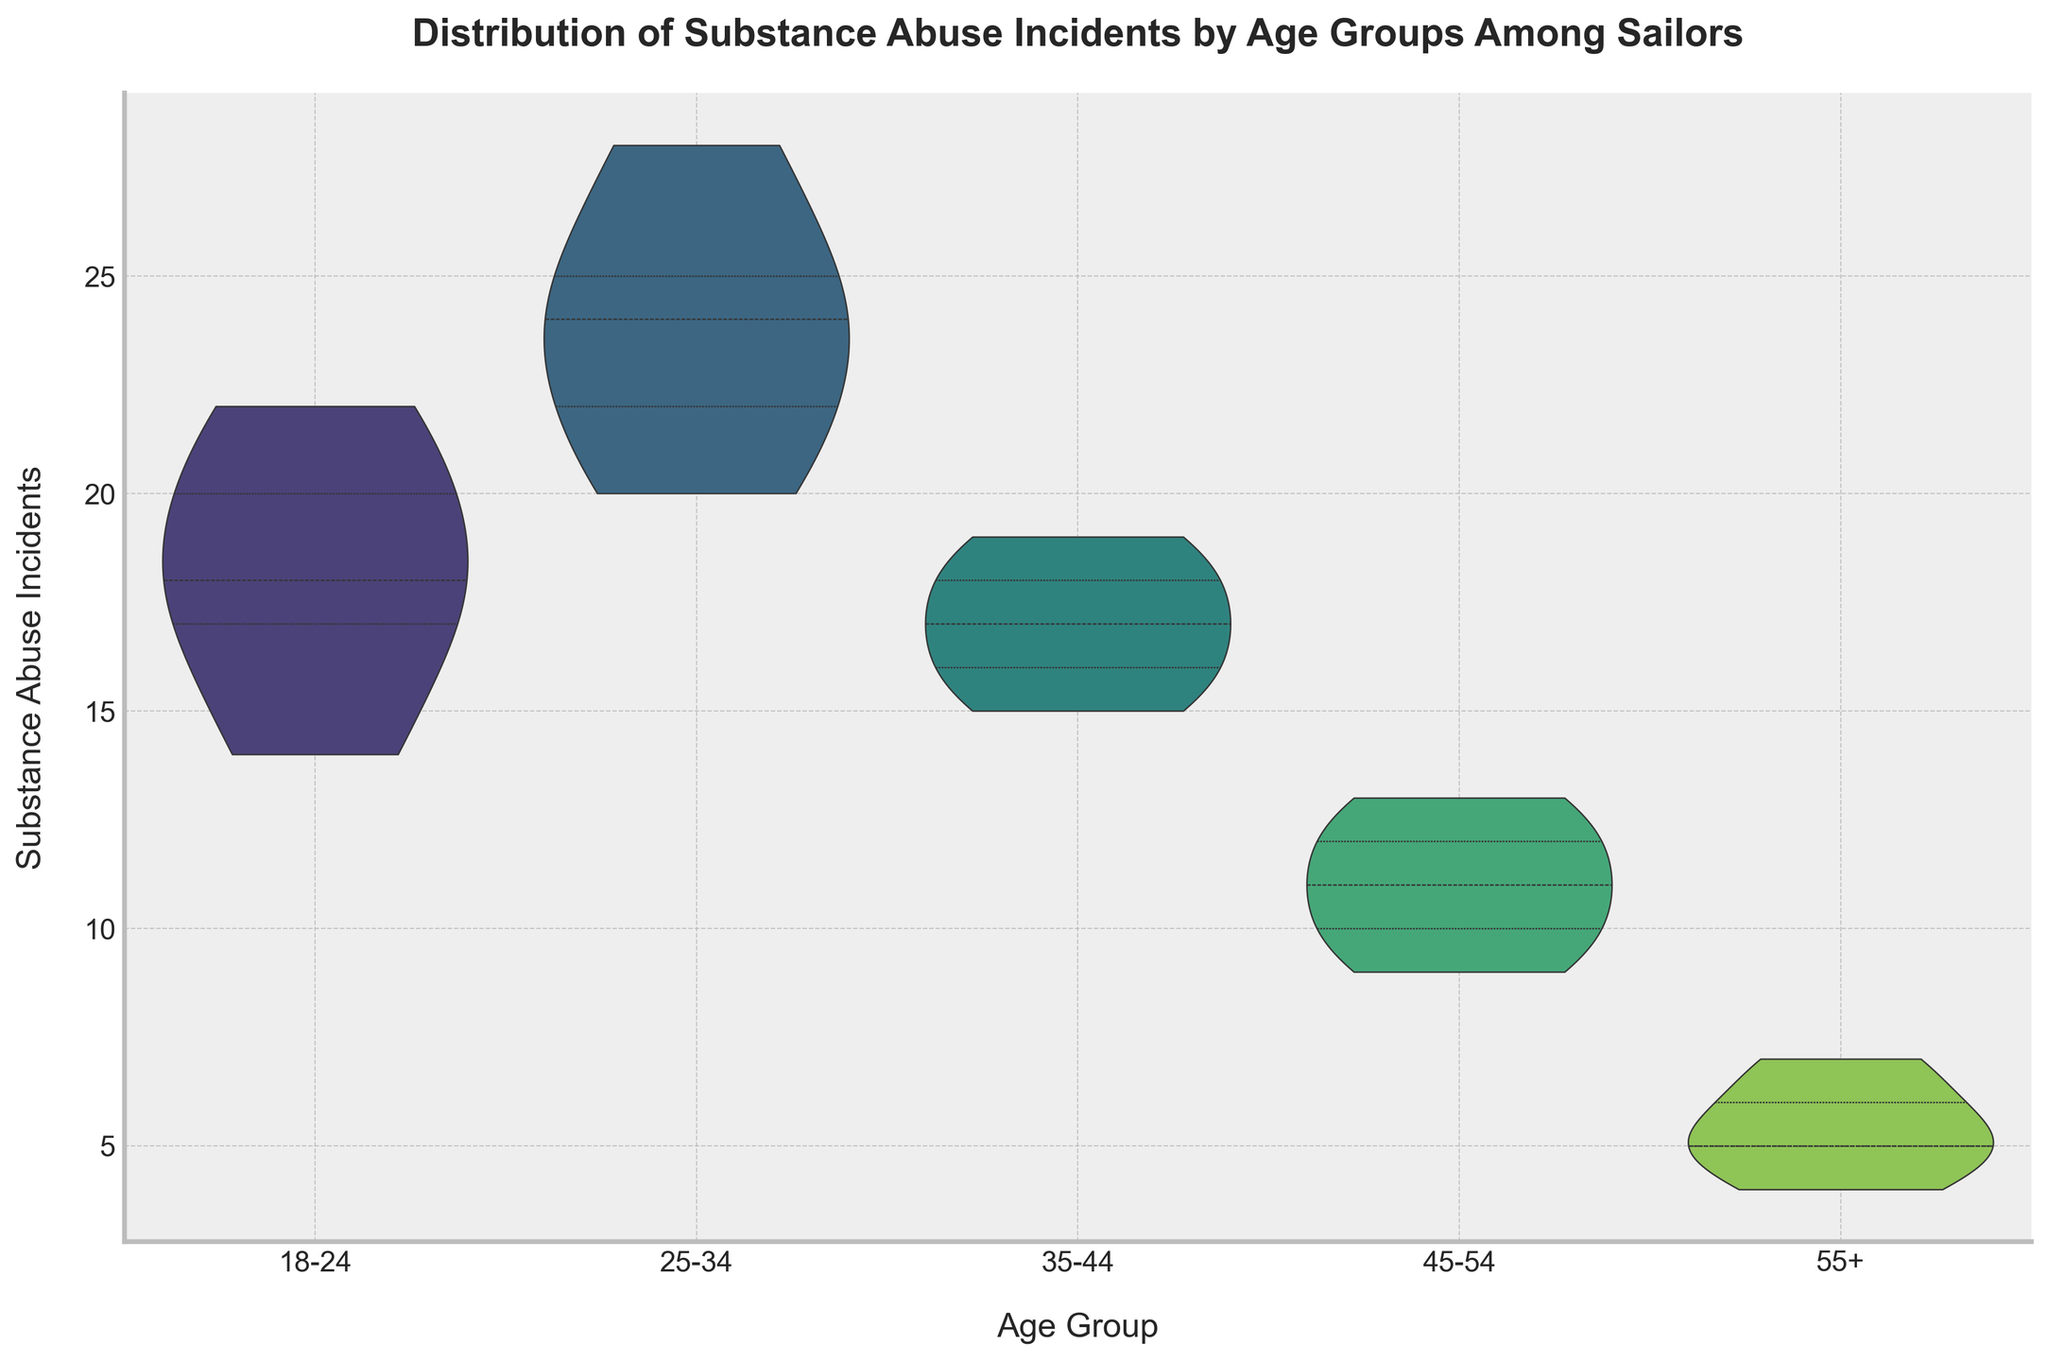What is the title of the figure? The title is generally displayed at the top of the chart, providing a summary of the data. Here, it likely reads "Distribution of Substance Abuse Incidents by Age Groups Among Sailors".
Answer: Distribution of Substance Abuse Incidents by Age Groups Among Sailors What age group has the widest range of substance abuse incidents? To determine this, look at the width of the violin plot for each age group. The 25-34 age group shows the widest range of incidents from the lowest (20) to the highest (28) values.
Answer: 25-34 Which age group exhibits the lowest median substance abuse incidents? The lowest median value is identified by the center line inside each violin plot. The age group 55+ has the lowest median value, represented by a median around 5-6 incidents.
Answer: 55+ How many quartiles are shown inside the violins? Each violin plot contains three internal lines (quartiles) which break down the incidents into segments. This represents the quartile ranges typical in a violin plot.
Answer: 3 Which age group has the most concentrated (densely packed) incidents around the mean? This is indicated by the thickness of the violin plot. The 18-24 age group appears to have the most concentrated distribution of incidents around the mean.
Answer: 18-24 Between which two age groups is the increase in highest incidents most significant? Compare the highest incidents for each age group. The increase from the 35-44 age group (highest around 19) to the 25-34 age group (highest around 28) is the most significant.
Answer: 35-44 to 25-34 Which age groups have overlapping ranges of substance abuse incidents? Overlapping ranges can be identified if the edges of the violins for different age groups touch or overlap for any value on the Y-axis. The 35-44 and 45-54 groups show overlapping ranges around the 10-15 value mark.
Answer: 35-44 and 45-54 What is the color palette used in the figure? The color palette is chosen to differentiate different segments visually. Here, the 'viridis' palette with a gradient of greens is used.
Answer: viridis Does the oldest age group show a significant spread in their incidents? The width of the violin plot for the 55+ age group is quite narrow, indicating a lesser spread or variability of incidents.
Answer: No Which age group has the smallest range of substance abuse incidents? By examining the range of each group's violin plot, the 55+ age group has the smallest spread of incidents, ranging from 4 to 7 incidents.
Answer: 55+ 